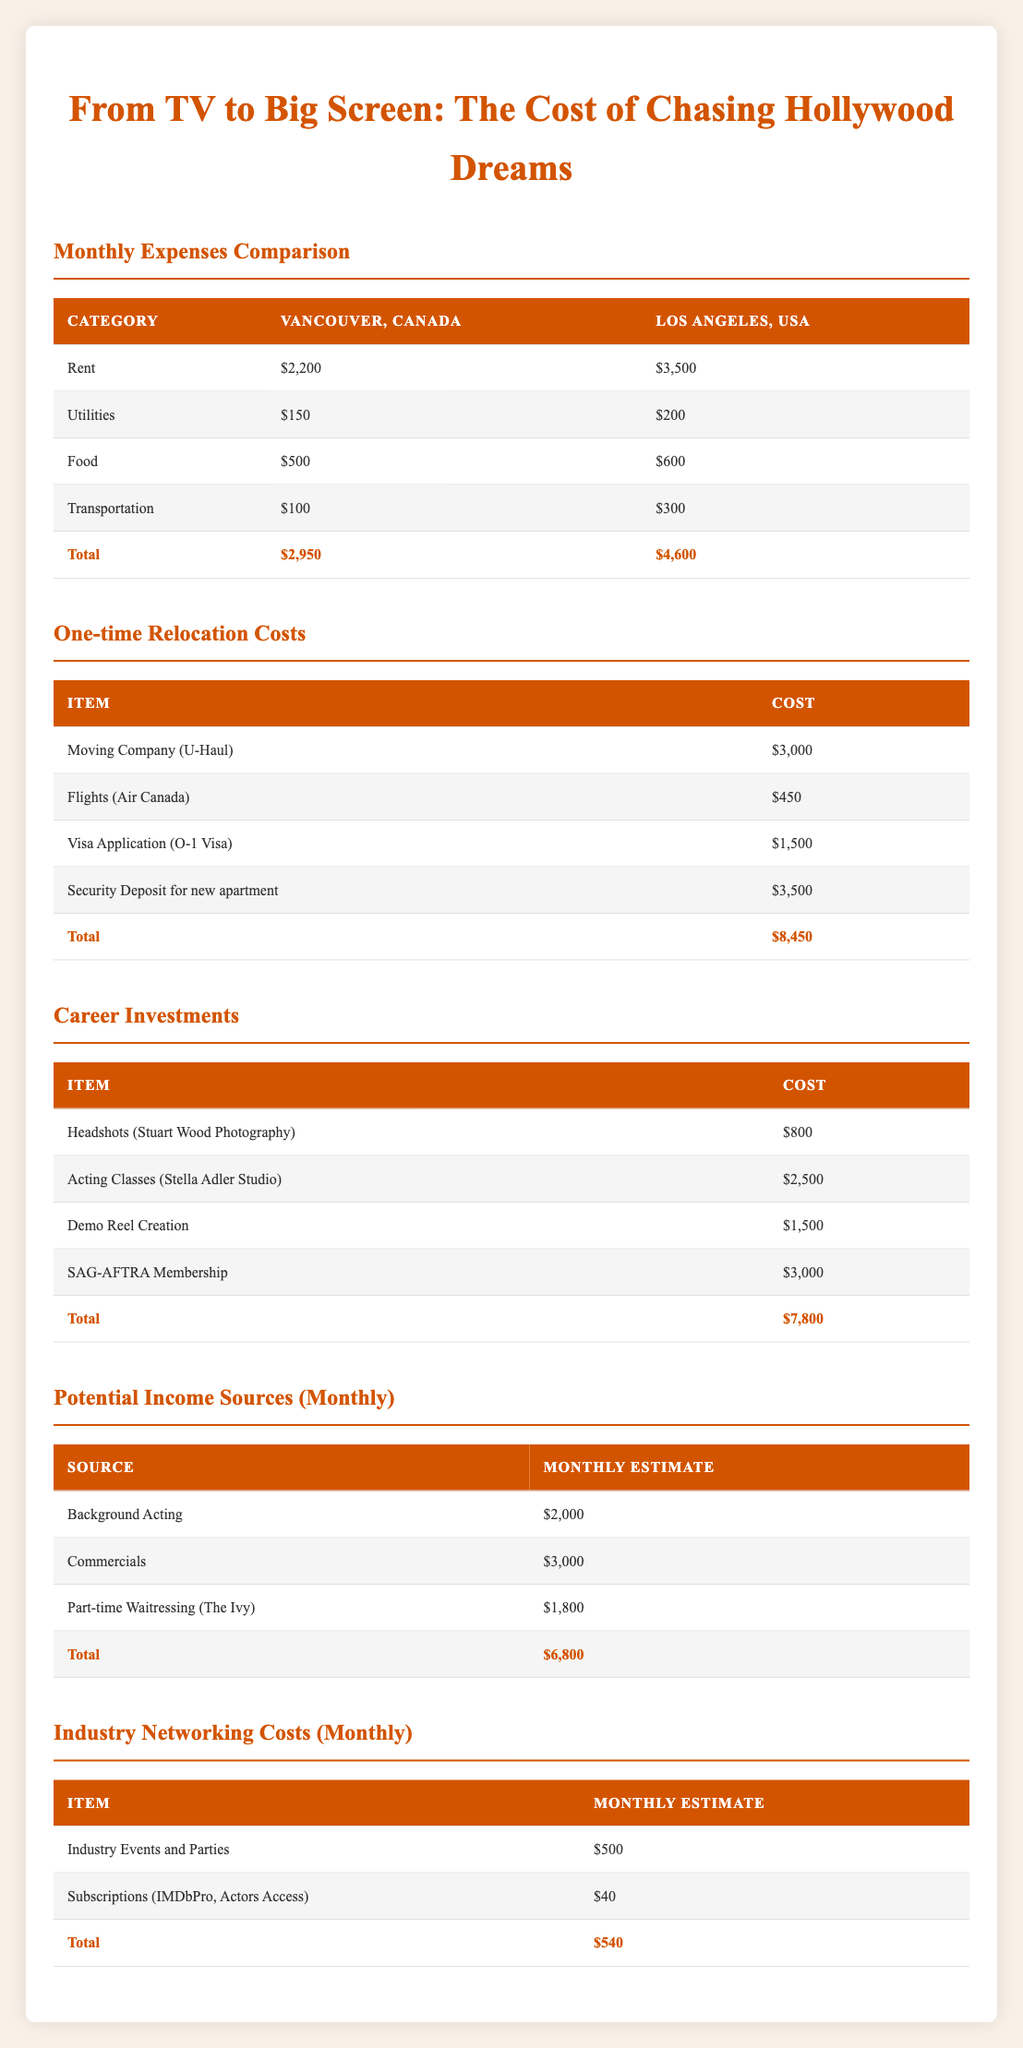What is the total monthly expense for living in Los Angeles? To find the total monthly expenses for Los Angeles, we sum up the monthly expenses: Rent ($3,500) + Utilities ($200) + Food ($600) + Transportation ($300) = $4,600.
Answer: $4,600 What is the difference in rent between Vancouver and Los Angeles? The rent in Vancouver is $2,200, and in Los Angeles, it is $3,500. The difference is $3,500 - $2,200 = $1,300.
Answer: $1,300 Is the total one-time relocation cost more than $7,000? We add the one-time costs together: Moving Company ($3,000) + Flights ($450) + Visa Application ($1,500) + Security Deposit ($3,500) = $8,450. Since $8,450 is greater than $7,000, the answer is yes.
Answer: Yes What are the total monthly potential income sources? The potential monthly incomes are: Background Acting ($2,000) + Commercials ($3,000) + Waitressing ($1,800) = $6,800. Therefore, the total is $6,800.
Answer: $6,800 Is the total cost of career investments higher than the total one-time relocation costs? We calculate the total career investments: Headshots ($800) + Acting Classes ($2,500) + Demo Reel Creation ($1,500) + SAG-AFTRA Membership ($3,000) = $7,800. Now, we compare $7,800 with the one-time relocation cost of $8,450. Since $7,800 is less than $8,450, the answer is no.
Answer: No If you add the total monthly expenses for both locations, what would it be? First, we find the total monthly expenses per location: Vancouver total ($2,950) + Los Angeles total ($4,600) = $7,550. Thus, the combined total is $7,550.
Answer: $7,550 How much more expensive is food in Los Angeles compared to Vancouver? The food expense in Vancouver is $500, while in Los Angeles, it is $600. The difference is $600 - $500 = $100.
Answer: $100 What is the total estimated cost for industry networking each month? We add the monthly costs for networking: Industry Events ($500) + Subscriptions ($40) = $540. So, the total estimated cost per month is $540.
Answer: $540 What is the total of all one-time relocation costs and career investments combined? The one-time relocation cost is $8,450, and the total for career investments is $7,800. We add those together: $8,450 + $7,800 = $16,250.
Answer: $16,250 